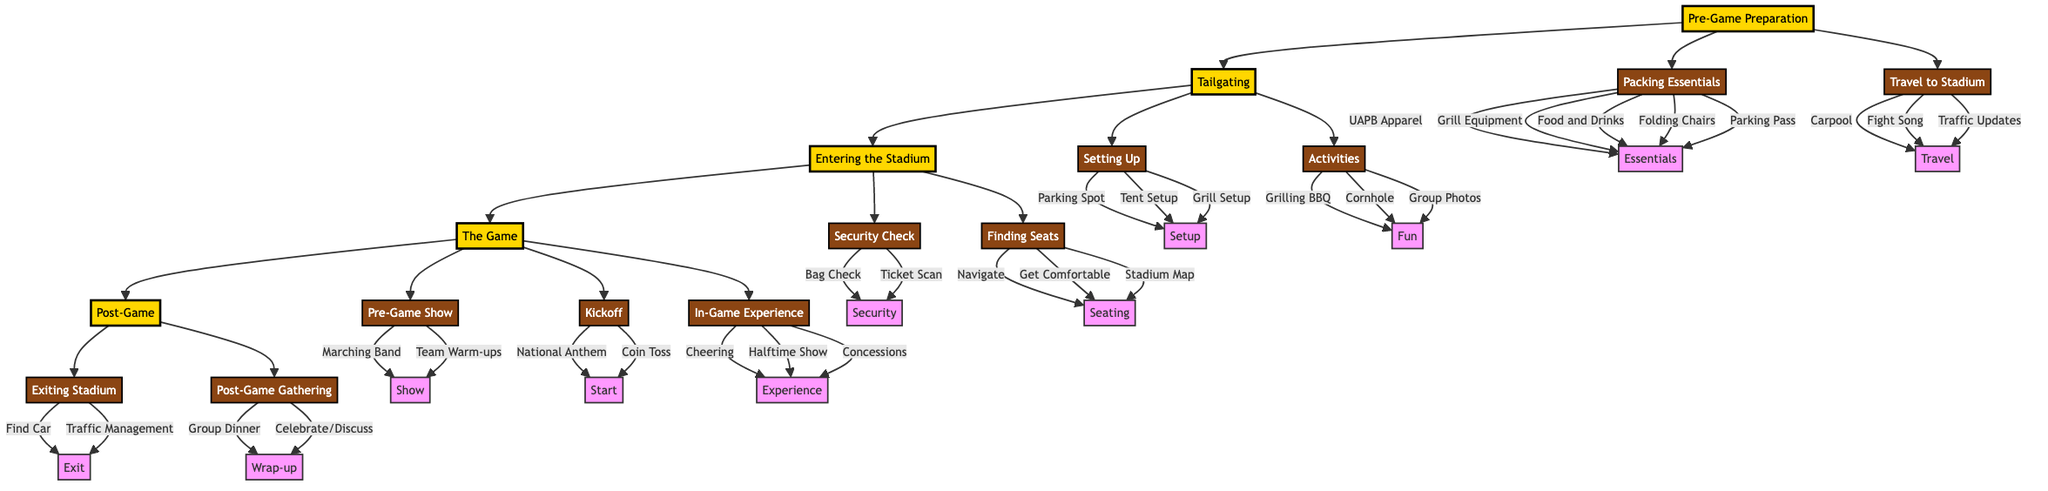What is the first step in the Game Day Experience? The first step listed in the diagram is "Pre-Game Preparation," which is the main starting point.
Answer: Pre-Game Preparation How many main sections are there in the diagram? By counting the main nodes represented in the diagram, there are five main sections: Pre-Game Preparation, Tailgating, Entering the Stadium, The Game, and Post-Game.
Answer: 5 What activities are involved in Tailgating? The diagram lists two sub-elements under Tailgating: "Setting Up" and "Activities," detailing various tasks such as setting up a tent and grilling BBQ.
Answer: Setting Up, Activities What is included in the "Packing Essentials"? The details provided under "Packing Essentials" include items like UAPB Apparel and Grill Equipment, which are essential for the game day preparation.
Answer: UAPB Apparel, Grill Equipment, Food and Drinks, Folding Chairs, Parking Pass Which element involves "Bag Check"? In the diagram, "Bag Check" is part of the "Security Check" sub-element under the "Entering the Stadium" main section.
Answer: Entering the Stadium What occurs right after the "Kickoff"? Following "Kickoff," which includes the National Anthem and Coin Toss elements, the diagram transitions into the "In-Game Experience," where attendees cheer for UAPB Golden Lions.
Answer: In-Game Experience How do fans celebrate after the game? The diagram illustrates that fans celebrate post-game through a "Post-Game Gathering," which includes group dinner and discussing the game outcome.
Answer: Group Dinner, Celebrating Victory or Discussing Game What is the last step in the diagram? The final main section in the diagram is "Post-Game," which summarizes the last phase of the game day experience following the conclusion of the game itself.
Answer: Post-Game What action is required before finding seats in the stadium? Before finding seats, the first action is completing the "Security Check," which incorporates Bag Check and Ticket Scan as essential steps.
Answer: Security Check 